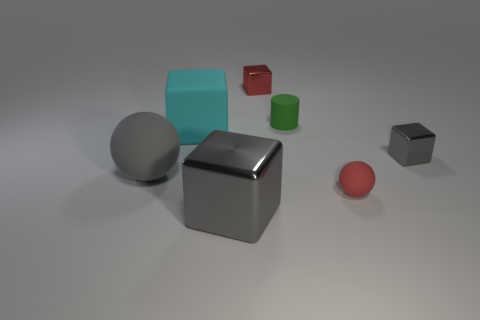What number of large brown blocks are there?
Your answer should be compact. 0. Is the number of big spheres that are behind the large rubber sphere greater than the number of tiny red rubber balls?
Offer a very short reply. No. What is the large cube that is in front of the small red matte thing made of?
Provide a succinct answer. Metal. There is another big metal thing that is the same shape as the cyan object; what color is it?
Give a very brief answer. Gray. What number of tiny things are the same color as the tiny cylinder?
Give a very brief answer. 0. Do the metal object that is right of the small green matte cylinder and the gray thing on the left side of the large rubber block have the same size?
Your answer should be compact. No. There is a red rubber thing; is its size the same as the gray metal cube that is in front of the tiny gray object?
Your response must be concise. No. How big is the cyan cube?
Your answer should be very brief. Large. What color is the cube that is the same material as the red ball?
Make the answer very short. Cyan. What number of cyan things have the same material as the small red cube?
Provide a succinct answer. 0. 